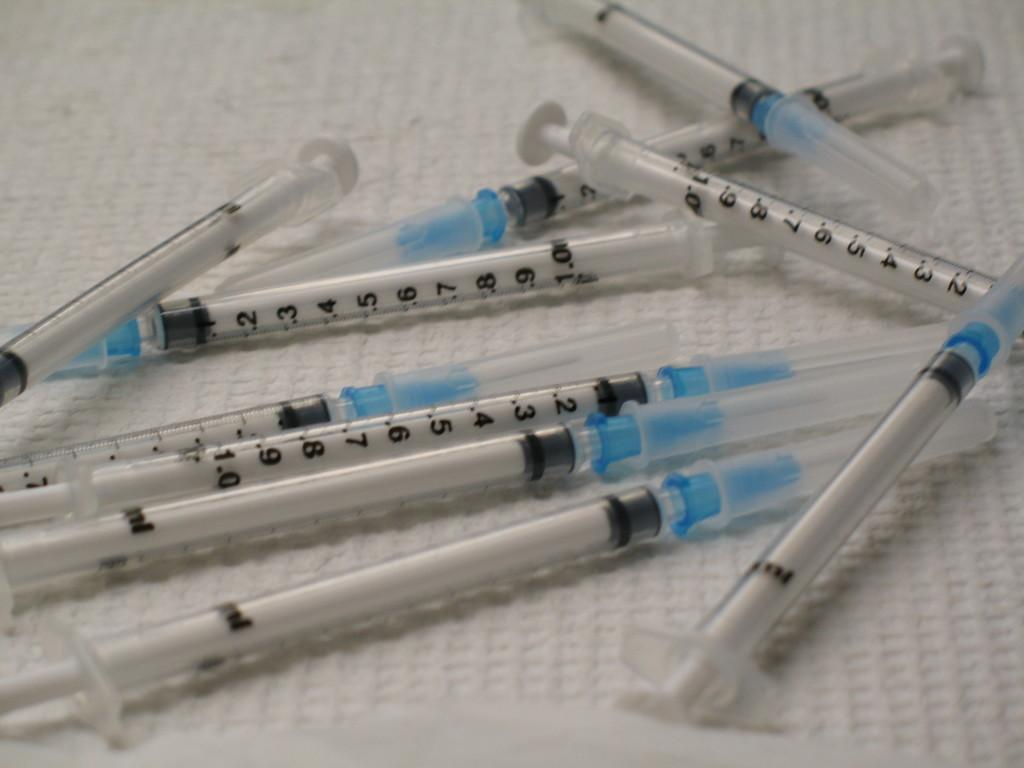What is present on the white cloth in the image? There are injections visible on the white cloth. Can you describe the appearance of the injections? The injections are visible on the white cloth, but no further details about their appearance are provided. What type of rose is depicted in the image? There is no rose present in the image; it features injections on a white cloth. What kind of juice is being served in the image? There is no juice present in the image; it only shows injections on a white cloth. 